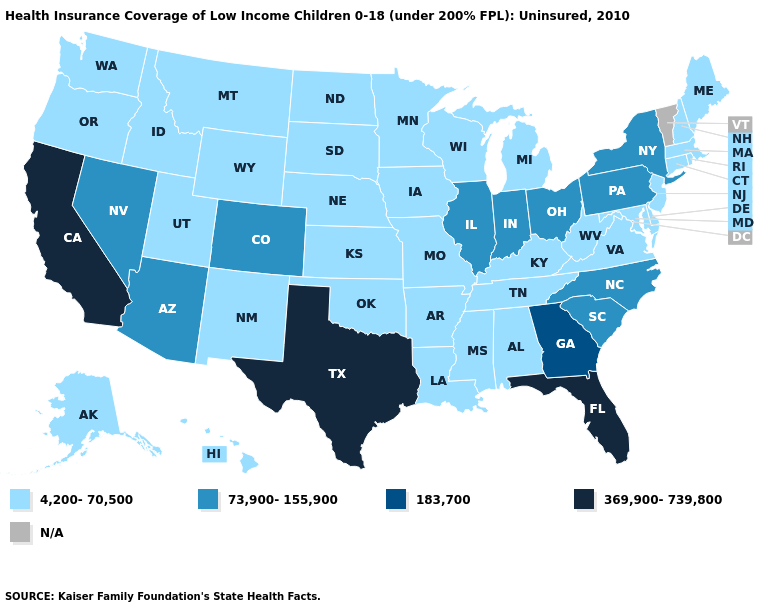Which states hav the highest value in the Northeast?
Give a very brief answer. New York, Pennsylvania. Which states have the lowest value in the USA?
Concise answer only. Alabama, Alaska, Arkansas, Connecticut, Delaware, Hawaii, Idaho, Iowa, Kansas, Kentucky, Louisiana, Maine, Maryland, Massachusetts, Michigan, Minnesota, Mississippi, Missouri, Montana, Nebraska, New Hampshire, New Jersey, New Mexico, North Dakota, Oklahoma, Oregon, Rhode Island, South Dakota, Tennessee, Utah, Virginia, Washington, West Virginia, Wisconsin, Wyoming. Name the states that have a value in the range N/A?
Write a very short answer. Vermont. Among the states that border Wisconsin , which have the lowest value?
Write a very short answer. Iowa, Michigan, Minnesota. Name the states that have a value in the range 183,700?
Be succinct. Georgia. Name the states that have a value in the range N/A?
Short answer required. Vermont. How many symbols are there in the legend?
Keep it brief. 5. What is the lowest value in the USA?
Write a very short answer. 4,200-70,500. What is the value of New Jersey?
Short answer required. 4,200-70,500. Does Florida have the highest value in the USA?
Concise answer only. Yes. Does Hawaii have the highest value in the West?
Keep it brief. No. What is the value of Wisconsin?
Be succinct. 4,200-70,500. What is the highest value in states that border Nevada?
Be succinct. 369,900-739,800. How many symbols are there in the legend?
Answer briefly. 5. 